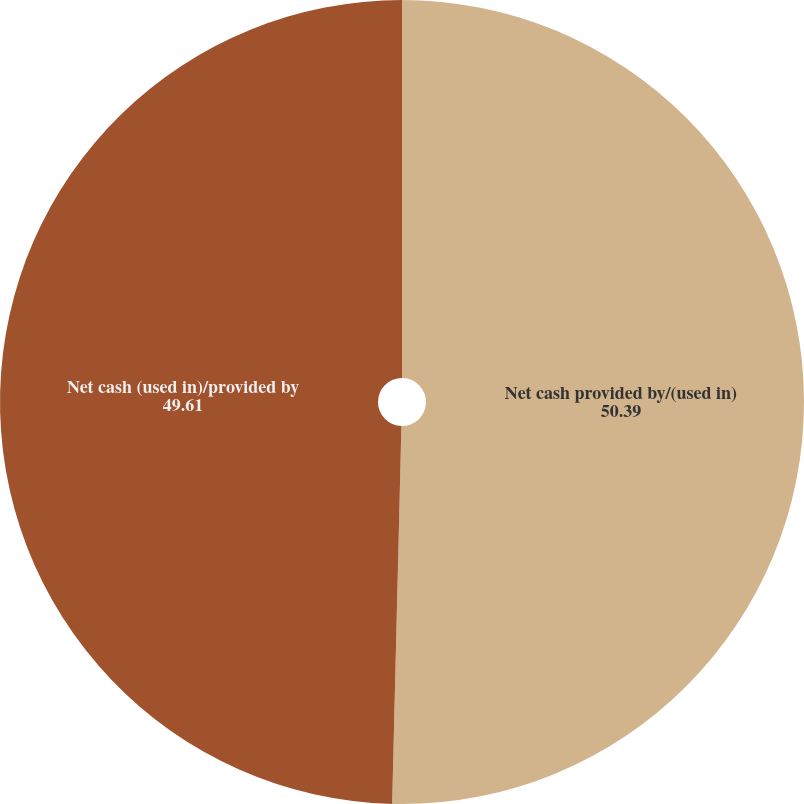Convert chart to OTSL. <chart><loc_0><loc_0><loc_500><loc_500><pie_chart><fcel>Net cash provided by/(used in)<fcel>Net cash (used in)/provided by<nl><fcel>50.39%<fcel>49.61%<nl></chart> 